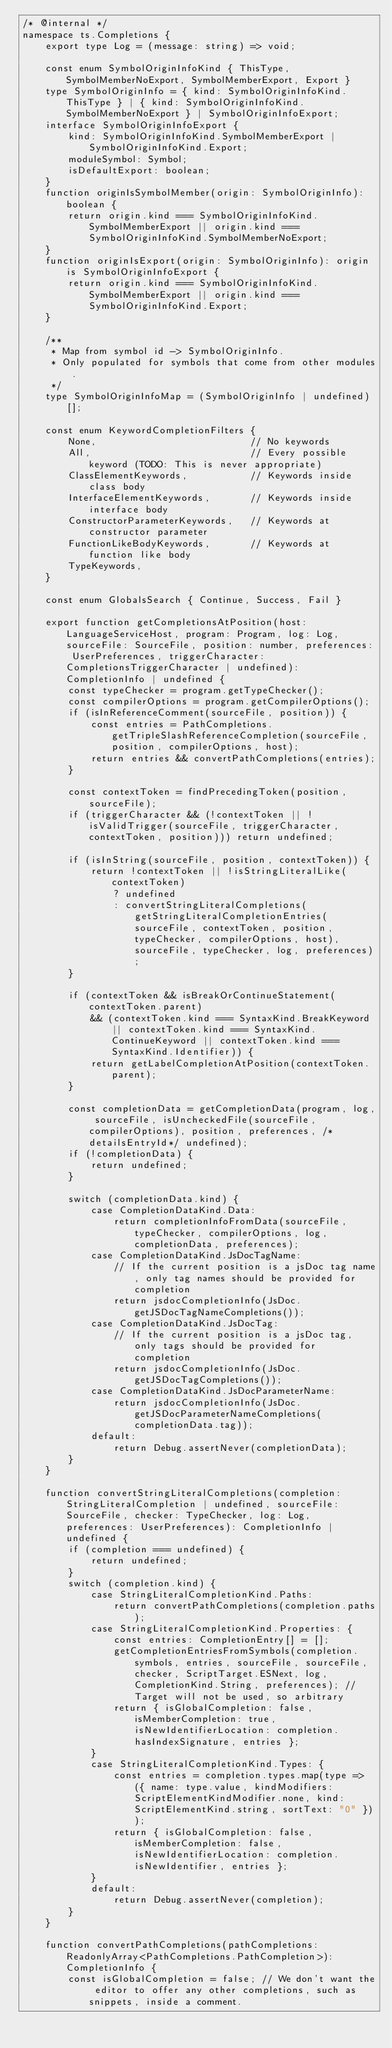Convert code to text. <code><loc_0><loc_0><loc_500><loc_500><_TypeScript_>/* @internal */
namespace ts.Completions {
    export type Log = (message: string) => void;

    const enum SymbolOriginInfoKind { ThisType, SymbolMemberNoExport, SymbolMemberExport, Export }
    type SymbolOriginInfo = { kind: SymbolOriginInfoKind.ThisType } | { kind: SymbolOriginInfoKind.SymbolMemberNoExport } | SymbolOriginInfoExport;
    interface SymbolOriginInfoExport {
        kind: SymbolOriginInfoKind.SymbolMemberExport | SymbolOriginInfoKind.Export;
        moduleSymbol: Symbol;
        isDefaultExport: boolean;
    }
    function originIsSymbolMember(origin: SymbolOriginInfo): boolean {
        return origin.kind === SymbolOriginInfoKind.SymbolMemberExport || origin.kind === SymbolOriginInfoKind.SymbolMemberNoExport;
    }
    function originIsExport(origin: SymbolOriginInfo): origin is SymbolOriginInfoExport {
        return origin.kind === SymbolOriginInfoKind.SymbolMemberExport || origin.kind === SymbolOriginInfoKind.Export;
    }

    /**
     * Map from symbol id -> SymbolOriginInfo.
     * Only populated for symbols that come from other modules.
     */
    type SymbolOriginInfoMap = (SymbolOriginInfo | undefined)[];

    const enum KeywordCompletionFilters {
        None,                           // No keywords
        All,                            // Every possible keyword (TODO: This is never appropriate)
        ClassElementKeywords,           // Keywords inside class body
        InterfaceElementKeywords,       // Keywords inside interface body
        ConstructorParameterKeywords,   // Keywords at constructor parameter
        FunctionLikeBodyKeywords,       // Keywords at function like body
        TypeKeywords,
    }

    const enum GlobalsSearch { Continue, Success, Fail }

    export function getCompletionsAtPosition(host: LanguageServiceHost, program: Program, log: Log, sourceFile: SourceFile, position: number, preferences: UserPreferences, triggerCharacter: CompletionsTriggerCharacter | undefined): CompletionInfo | undefined {
        const typeChecker = program.getTypeChecker();
        const compilerOptions = program.getCompilerOptions();
        if (isInReferenceComment(sourceFile, position)) {
            const entries = PathCompletions.getTripleSlashReferenceCompletion(sourceFile, position, compilerOptions, host);
            return entries && convertPathCompletions(entries);
        }

        const contextToken = findPrecedingToken(position, sourceFile);
        if (triggerCharacter && (!contextToken || !isValidTrigger(sourceFile, triggerCharacter, contextToken, position))) return undefined;

        if (isInString(sourceFile, position, contextToken)) {
            return !contextToken || !isStringLiteralLike(contextToken)
                ? undefined
                : convertStringLiteralCompletions(getStringLiteralCompletionEntries(sourceFile, contextToken, position, typeChecker, compilerOptions, host), sourceFile, typeChecker, log, preferences);
        }

        if (contextToken && isBreakOrContinueStatement(contextToken.parent)
            && (contextToken.kind === SyntaxKind.BreakKeyword || contextToken.kind === SyntaxKind.ContinueKeyword || contextToken.kind === SyntaxKind.Identifier)) {
            return getLabelCompletionAtPosition(contextToken.parent);
        }

        const completionData = getCompletionData(program, log, sourceFile, isUncheckedFile(sourceFile, compilerOptions), position, preferences, /*detailsEntryId*/ undefined);
        if (!completionData) {
            return undefined;
        }

        switch (completionData.kind) {
            case CompletionDataKind.Data:
                return completionInfoFromData(sourceFile, typeChecker, compilerOptions, log, completionData, preferences);
            case CompletionDataKind.JsDocTagName:
                // If the current position is a jsDoc tag name, only tag names should be provided for completion
                return jsdocCompletionInfo(JsDoc.getJSDocTagNameCompletions());
            case CompletionDataKind.JsDocTag:
                // If the current position is a jsDoc tag, only tags should be provided for completion
                return jsdocCompletionInfo(JsDoc.getJSDocTagCompletions());
            case CompletionDataKind.JsDocParameterName:
                return jsdocCompletionInfo(JsDoc.getJSDocParameterNameCompletions(completionData.tag));
            default:
                return Debug.assertNever(completionData);
        }
    }

    function convertStringLiteralCompletions(completion: StringLiteralCompletion | undefined, sourceFile: SourceFile, checker: TypeChecker, log: Log, preferences: UserPreferences): CompletionInfo | undefined {
        if (completion === undefined) {
            return undefined;
        }
        switch (completion.kind) {
            case StringLiteralCompletionKind.Paths:
                return convertPathCompletions(completion.paths);
            case StringLiteralCompletionKind.Properties: {
                const entries: CompletionEntry[] = [];
                getCompletionEntriesFromSymbols(completion.symbols, entries, sourceFile, sourceFile, checker, ScriptTarget.ESNext, log, CompletionKind.String, preferences); // Target will not be used, so arbitrary
                return { isGlobalCompletion: false, isMemberCompletion: true, isNewIdentifierLocation: completion.hasIndexSignature, entries };
            }
            case StringLiteralCompletionKind.Types: {
                const entries = completion.types.map(type => ({ name: type.value, kindModifiers: ScriptElementKindModifier.none, kind: ScriptElementKind.string, sortText: "0" }));
                return { isGlobalCompletion: false, isMemberCompletion: false, isNewIdentifierLocation: completion.isNewIdentifier, entries };
            }
            default:
                return Debug.assertNever(completion);
        }
    }

    function convertPathCompletions(pathCompletions: ReadonlyArray<PathCompletions.PathCompletion>): CompletionInfo {
        const isGlobalCompletion = false; // We don't want the editor to offer any other completions, such as snippets, inside a comment.</code> 